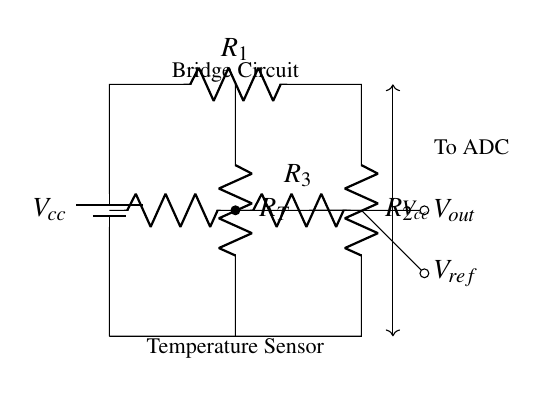What is the type of the circuit depicted? The circuit is a balanced bridge circuit, which uses resistors to create a condition where the voltage across the bridge is zero for precise measurement, typically used for sensing applications.
Answer: balanced bridge circuit What is the purpose of R_T in this circuit? R_T is the temperature sensor resistor, which changes its resistance value in response to temperature changes. This change affects the balance of the bridge, allowing for precise temperature measurement based on voltage output variations.
Answer: temperature sensor What does V_out represent in the diagram? V_out represents the output voltage of the bridge circuit, which is used to determine the difference in potential caused by the change in resistance of the temperature sensor compared to the reference resistor values.
Answer: output voltage What is the total voltage supplied to the circuit? The total voltage, denoted as V_cc, is supplied by the battery in the circuit. In typical applications, this value can vary, but it is the source voltage that powers the bridge.
Answer: V_cc How many resistors are present in the circuit? There are four resistors in the circuit: R_1, R_2, R_3, and R_T. They form the arms of the bridge, with R_T specifically acting as the variable resistor influenced by temperature changes.
Answer: four How is V_ref related to the bridge balance? V_ref is the reference voltage across one side of the bridge. For the bridge to be balanced (where V_out is zero), V_ref must equal the voltage across the other side formed by R_1 and R_2 when R_3 is adjusted accordingly to keep balance.
Answer: reference voltage What is the significance of the connection labeled "To ADC"? The connection labeled "To ADC" indicates that the output voltage V_out will be sent to an Analog-to-Digital Converter (ADC), where it can be digitized for further processing or monitoring in a smart thermostat system.
Answer: digital conversion 